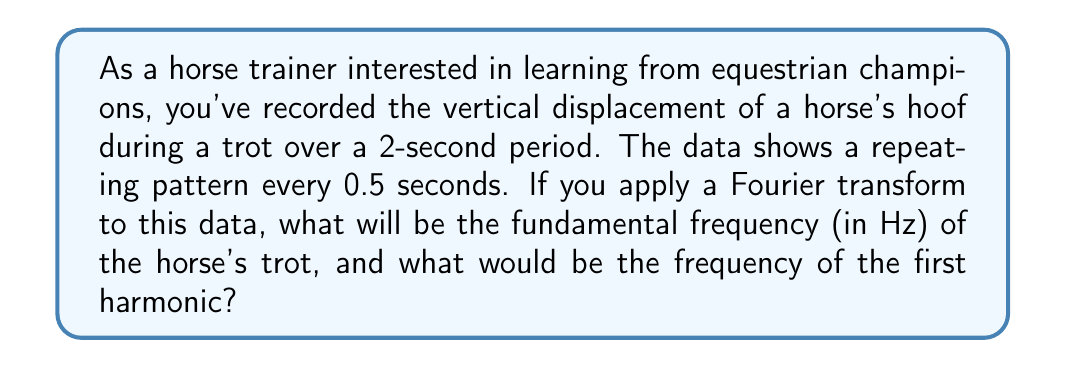Teach me how to tackle this problem. Let's approach this step-by-step:

1) First, we need to understand what the Fourier transform does. It decomposes a signal into its constituent frequencies. In this case, our signal is the vertical displacement of the horse's hoof over time.

2) The fundamental frequency is the lowest frequency component of a periodic waveform. It's the reciprocal of the period of the waveform.

3) We're told that the pattern repeats every 0.5 seconds. This is the period (T) of our signal.

4) The fundamental frequency (f) is given by:

   $$f = \frac{1}{T}$$

   Where T is the period of the signal.

5) Substituting our values:

   $$f = \frac{1}{0.5 \text{ s}} = 2 \text{ Hz}$$

6) The first harmonic is the second frequency component in the Fourier series, which is twice the fundamental frequency.

7) Therefore, the frequency of the first harmonic is:

   $$f_1 = 2f = 2 * 2 \text{ Hz} = 4 \text{ Hz}$$

This analysis shows that the horse's trot has a fundamental frequency of 2 Hz (2 cycles per second) and a first harmonic at 4 Hz.
Answer: The fundamental frequency is 2 Hz, and the frequency of the first harmonic is 4 Hz. 